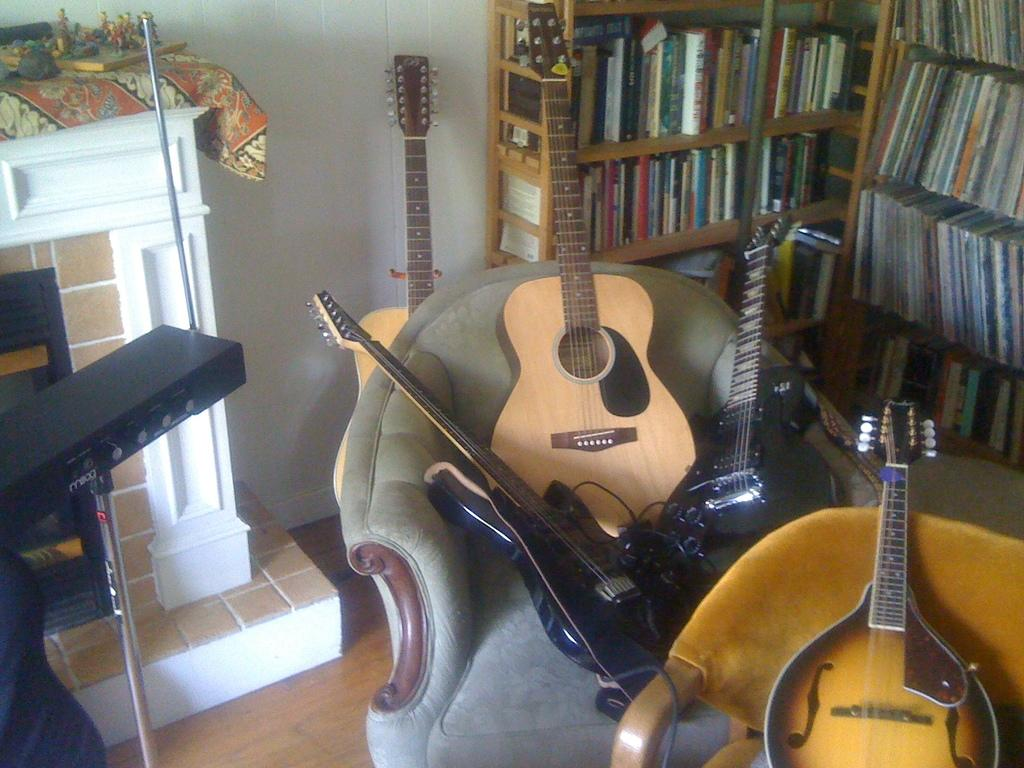What is the color of the wall in the image? The wall in the image is white. What is on the rack in the image? There is a rack filled with books in the image. Where are the guitars located in the image? The guitars are on the sofas in the image. What type of flowers are on the title of the book in the image? There are no flowers or titles of books visible in the image. What is the process of creating the guitars on the sofas in the image? The image does not show the process of creating the guitars; it only shows the guitars on the sofas. 